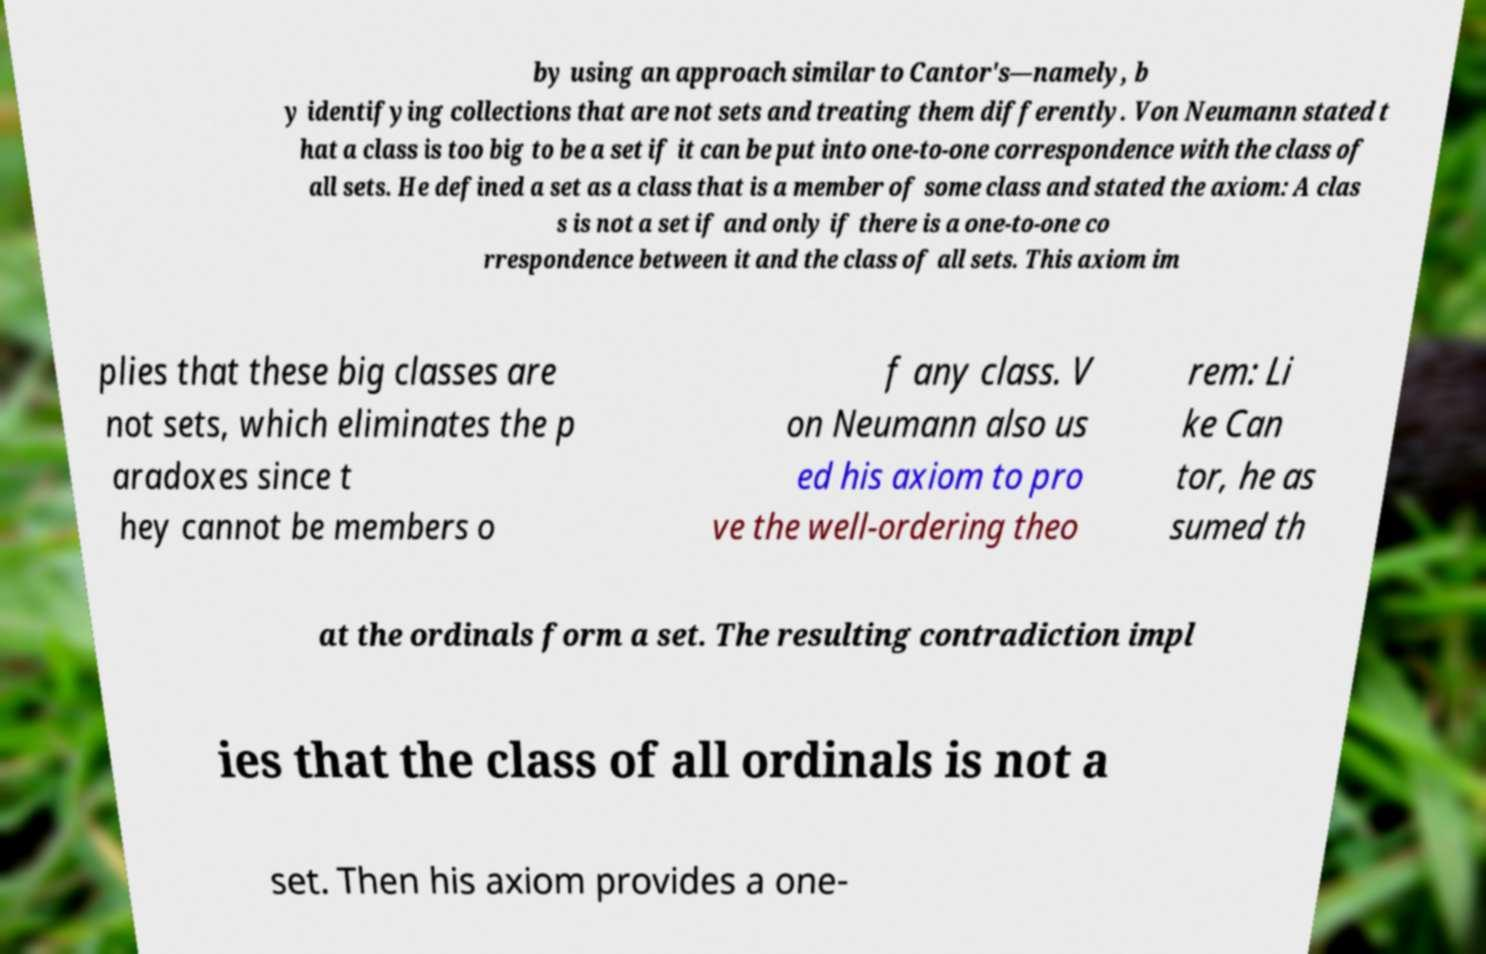I need the written content from this picture converted into text. Can you do that? by using an approach similar to Cantor's—namely, b y identifying collections that are not sets and treating them differently. Von Neumann stated t hat a class is too big to be a set if it can be put into one-to-one correspondence with the class of all sets. He defined a set as a class that is a member of some class and stated the axiom: A clas s is not a set if and only if there is a one-to-one co rrespondence between it and the class of all sets. This axiom im plies that these big classes are not sets, which eliminates the p aradoxes since t hey cannot be members o f any class. V on Neumann also us ed his axiom to pro ve the well-ordering theo rem: Li ke Can tor, he as sumed th at the ordinals form a set. The resulting contradiction impl ies that the class of all ordinals is not a set. Then his axiom provides a one- 